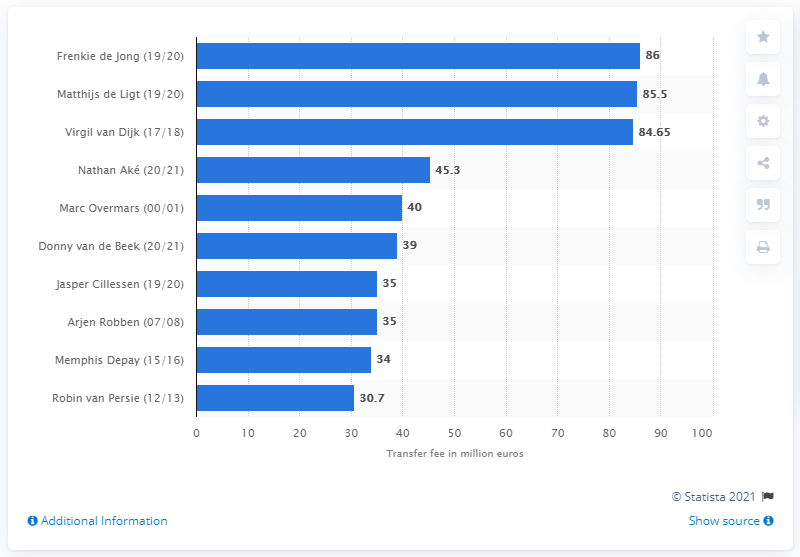Give some essential details in this illustration. Liverpool paid a staggering 85.5 million dollars for the acquisition of Virgil van Dijk, solidifying their status as a top European football club. Matthijs de Ligt was acquired by Juventus FC for a transfer fee of 86 million euros. 